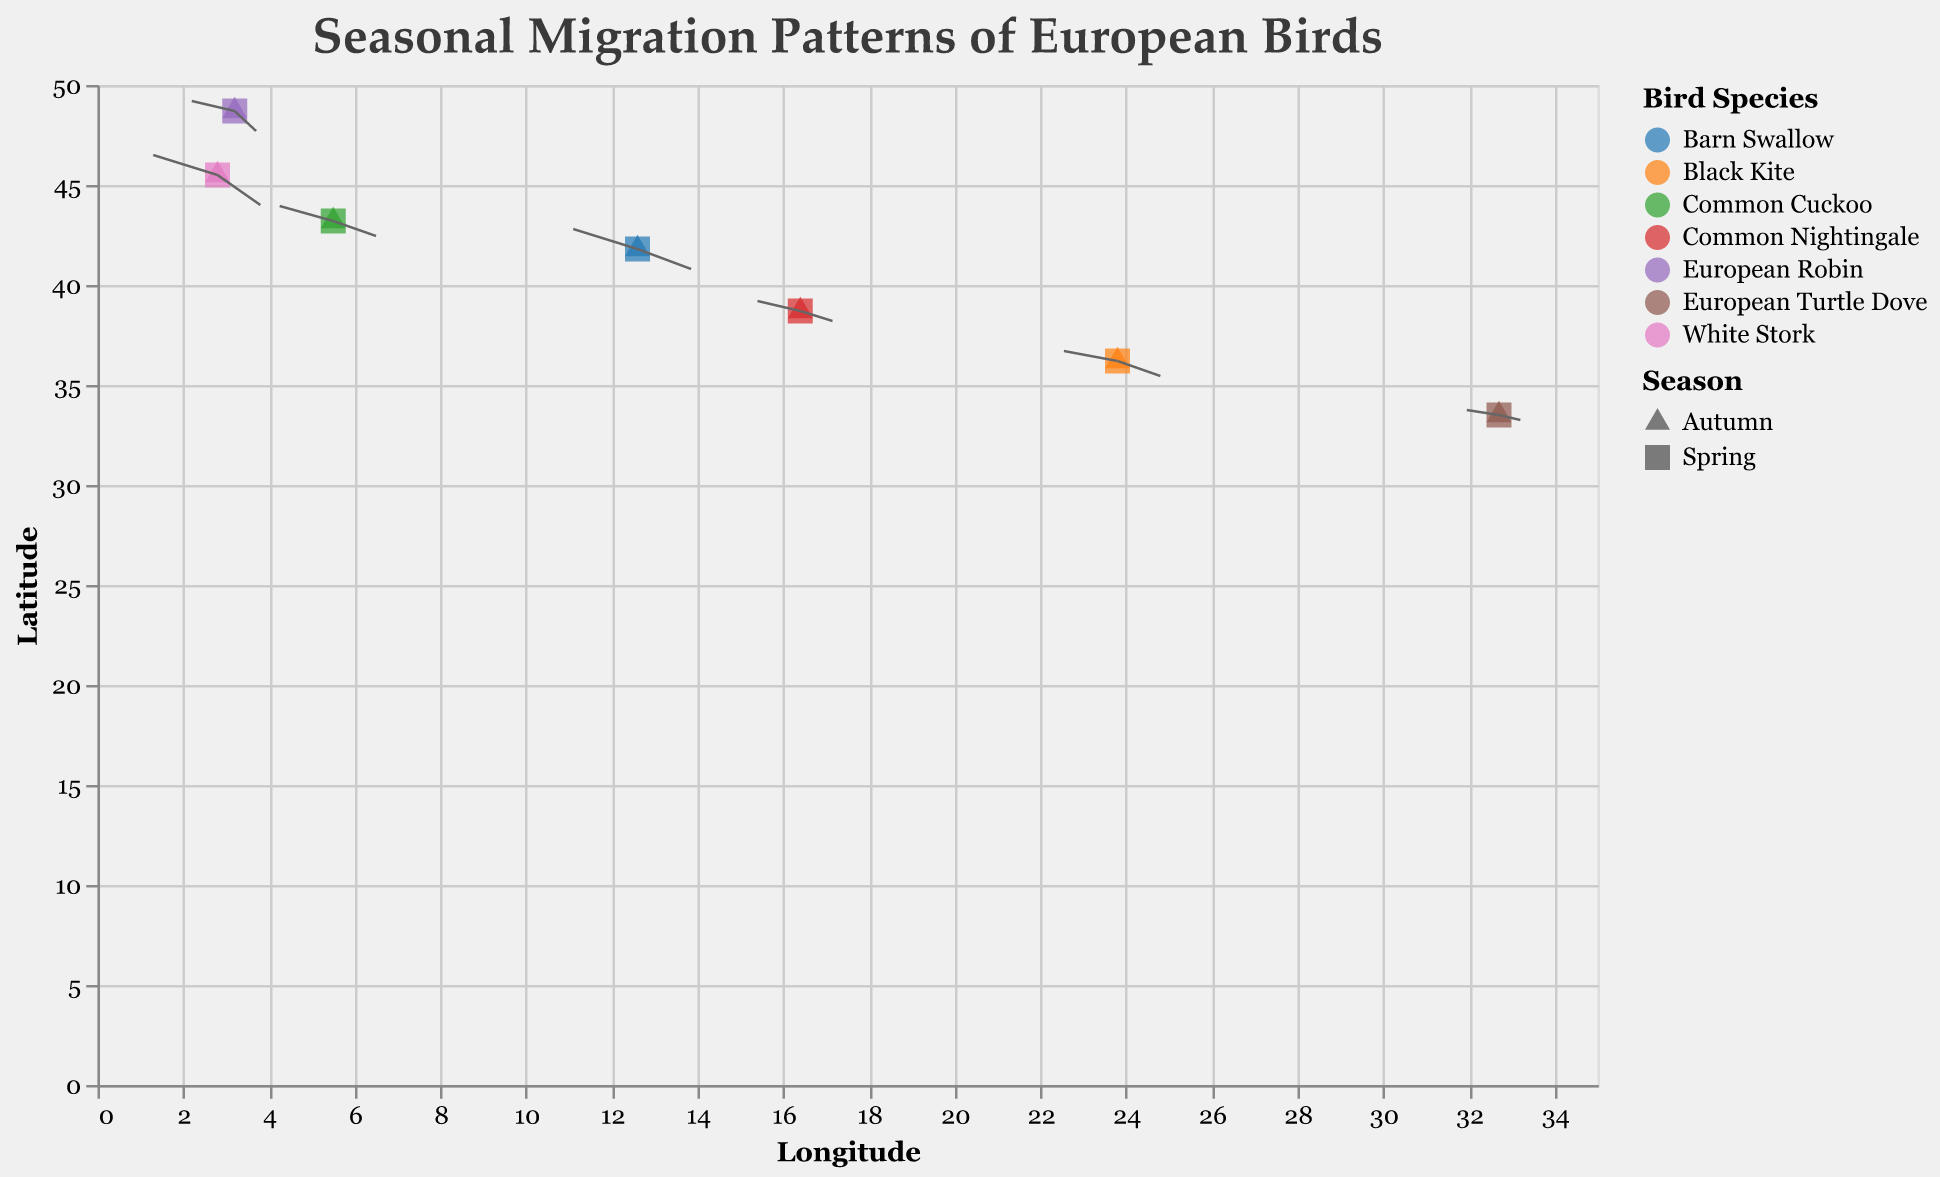What is the title of the figure? The title of the figure is usually at the top and gives a concise description of the content. Here, it reads "Seasonal Migration Patterns of European Birds".
Answer: Seasonal Migration Patterns of European Birds Which bird species is represented by the point at latitude 45.5 and longitude 2.8? To determine this, find the point at latitude 45.5 and longitude 2.8 in the figure. The species associated with this point is "White Stork".
Answer: White Stork What is the color scheme used to distinguish different bird species? The color of each bird species in the plot is derived from the categorical color scheme. The legend shows each species is color-coded using the category10 scheme.
Answer: category10 colors How does the migration pattern of the European Robin differ between Spring and Autumn? For the European Robin, look for points and arrows starting from the same location but pointing in different directions depending on the season. In Spring, the arrow points left-downwards, while in Autumn, it points right-downwards.
Answer: Spring: left-down, Autumn: right-down Which bird species migrate the farthest during Spring? Measure the length of each arrow in Spring to determine the distance. The White Stork has the longest arrow indicating it migrates the farthest during Spring.
Answer: White Stork Compare the migration distance of Black Kite during Spring and Autumn. Look at the length of the arrows for Black Kite in both seasons at the location latitude 36.2, longitude 23.8. The arrows are roughly the same length, indicating similar migration distances in both Spring and Autumn.
Answer: Similar distance What shape represents migration patterns in the Autumn season? In the legend, the shape for Autumn is specified. It is a square.
Answer: Square What is the latitude and longitude of the European Turtle Dove? Look for the European Turtle Dove in the provided data points. It is located at latitude 33.5 and longitude 32.7.
Answer: Latitude: 33.5, Longitude: 32.7 During which season does the Barn Swallow migrate towards higher longitudes? Look at the data points for Barn Swallow. In Autumn, the arrow points towards higher longitudes.
Answer: Autumn 